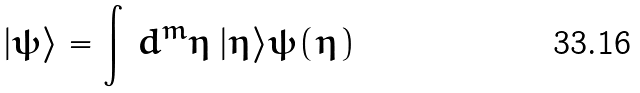<formula> <loc_0><loc_0><loc_500><loc_500>| \psi \rangle = \int \, d ^ { m } \eta \, | \eta \rangle \psi ( \eta )</formula> 